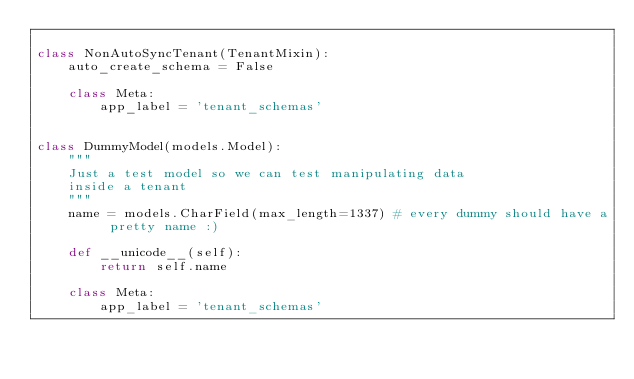<code> <loc_0><loc_0><loc_500><loc_500><_Python_>
class NonAutoSyncTenant(TenantMixin):
    auto_create_schema = False

    class Meta:
        app_label = 'tenant_schemas'


class DummyModel(models.Model):
    """
    Just a test model so we can test manipulating data
    inside a tenant
    """
    name = models.CharField(max_length=1337) # every dummy should have a pretty name :)

    def __unicode__(self):
        return self.name

    class Meta:
        app_label = 'tenant_schemas'</code> 